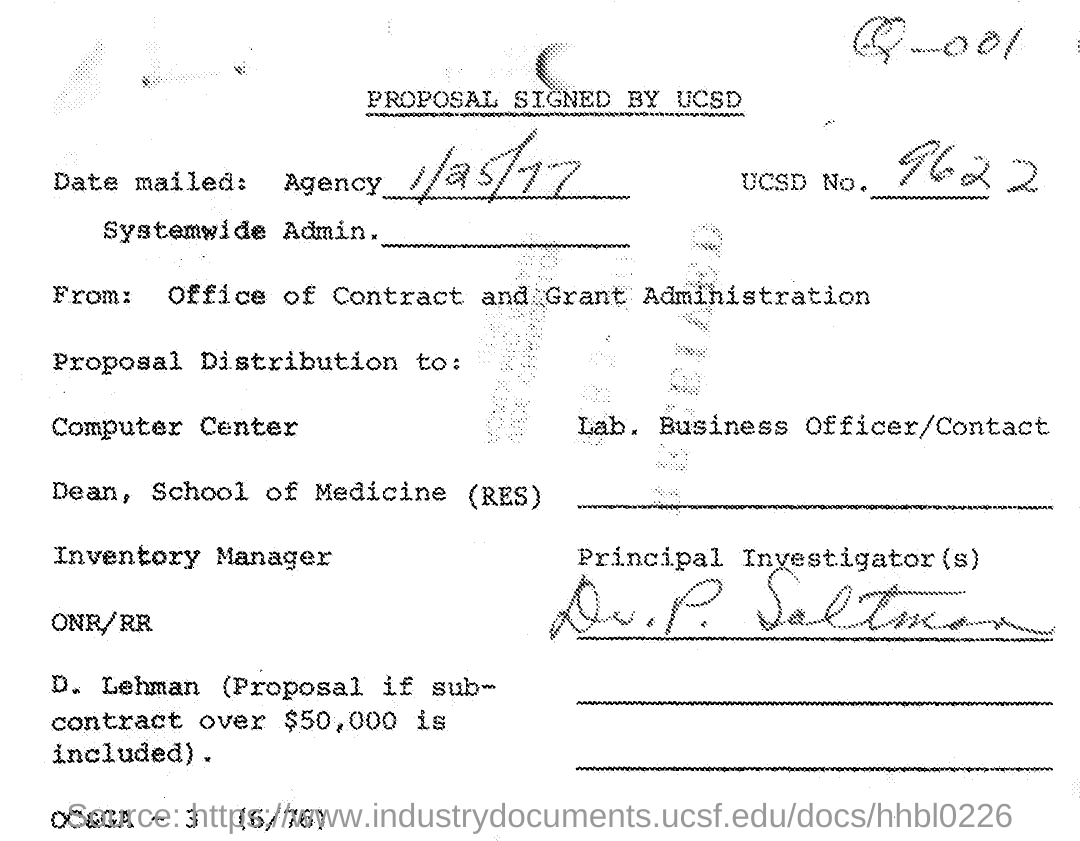When was this mailed?
Your answer should be compact. 1/25/77. 